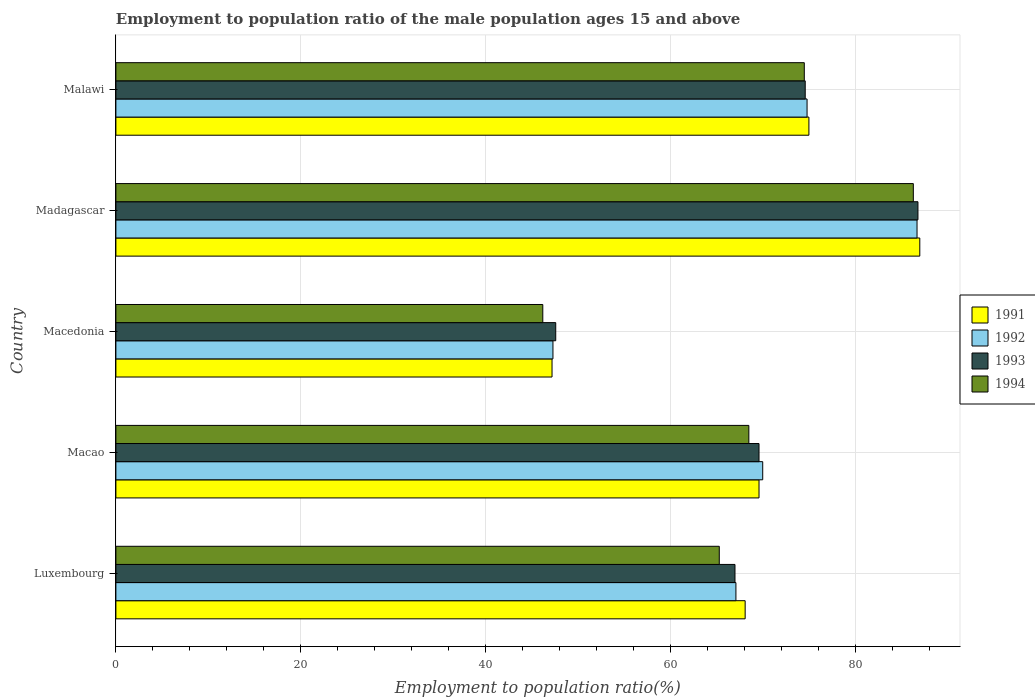How many different coloured bars are there?
Offer a very short reply. 4. How many groups of bars are there?
Offer a very short reply. 5. Are the number of bars per tick equal to the number of legend labels?
Provide a succinct answer. Yes. Are the number of bars on each tick of the Y-axis equal?
Your answer should be very brief. Yes. How many bars are there on the 2nd tick from the bottom?
Provide a succinct answer. 4. What is the label of the 5th group of bars from the top?
Provide a succinct answer. Luxembourg. What is the employment to population ratio in 1992 in Malawi?
Give a very brief answer. 74.8. Across all countries, what is the maximum employment to population ratio in 1992?
Give a very brief answer. 86.7. Across all countries, what is the minimum employment to population ratio in 1992?
Provide a short and direct response. 47.3. In which country was the employment to population ratio in 1991 maximum?
Provide a short and direct response. Madagascar. In which country was the employment to population ratio in 1992 minimum?
Your answer should be compact. Macedonia. What is the total employment to population ratio in 1994 in the graph?
Your response must be concise. 340.8. What is the difference between the employment to population ratio in 1994 in Macedonia and that in Malawi?
Your answer should be very brief. -28.3. What is the difference between the employment to population ratio in 1992 in Luxembourg and the employment to population ratio in 1993 in Madagascar?
Provide a succinct answer. -19.7. What is the average employment to population ratio in 1994 per country?
Ensure brevity in your answer.  68.16. What is the difference between the employment to population ratio in 1992 and employment to population ratio in 1993 in Macao?
Give a very brief answer. 0.4. In how many countries, is the employment to population ratio in 1991 greater than 32 %?
Offer a very short reply. 5. What is the ratio of the employment to population ratio in 1992 in Luxembourg to that in Macao?
Offer a terse response. 0.96. Is the employment to population ratio in 1994 in Luxembourg less than that in Malawi?
Offer a terse response. Yes. Is the difference between the employment to population ratio in 1992 in Madagascar and Malawi greater than the difference between the employment to population ratio in 1993 in Madagascar and Malawi?
Offer a very short reply. No. What is the difference between the highest and the second highest employment to population ratio in 1992?
Provide a short and direct response. 11.9. What is the difference between the highest and the lowest employment to population ratio in 1993?
Your answer should be compact. 39.2. Is it the case that in every country, the sum of the employment to population ratio in 1992 and employment to population ratio in 1994 is greater than the sum of employment to population ratio in 1991 and employment to population ratio in 1993?
Offer a terse response. No. Is it the case that in every country, the sum of the employment to population ratio in 1991 and employment to population ratio in 1994 is greater than the employment to population ratio in 1993?
Make the answer very short. Yes. Are all the bars in the graph horizontal?
Provide a succinct answer. Yes. How many countries are there in the graph?
Offer a terse response. 5. Are the values on the major ticks of X-axis written in scientific E-notation?
Make the answer very short. No. Does the graph contain grids?
Keep it short and to the point. Yes. Where does the legend appear in the graph?
Your response must be concise. Center right. What is the title of the graph?
Provide a short and direct response. Employment to population ratio of the male population ages 15 and above. What is the label or title of the Y-axis?
Ensure brevity in your answer.  Country. What is the Employment to population ratio(%) in 1991 in Luxembourg?
Keep it short and to the point. 68.1. What is the Employment to population ratio(%) in 1992 in Luxembourg?
Offer a terse response. 67.1. What is the Employment to population ratio(%) in 1993 in Luxembourg?
Offer a terse response. 67. What is the Employment to population ratio(%) in 1994 in Luxembourg?
Your response must be concise. 65.3. What is the Employment to population ratio(%) in 1991 in Macao?
Ensure brevity in your answer.  69.6. What is the Employment to population ratio(%) in 1992 in Macao?
Your answer should be compact. 70. What is the Employment to population ratio(%) of 1993 in Macao?
Give a very brief answer. 69.6. What is the Employment to population ratio(%) of 1994 in Macao?
Give a very brief answer. 68.5. What is the Employment to population ratio(%) of 1991 in Macedonia?
Provide a succinct answer. 47.2. What is the Employment to population ratio(%) of 1992 in Macedonia?
Your response must be concise. 47.3. What is the Employment to population ratio(%) in 1993 in Macedonia?
Provide a short and direct response. 47.6. What is the Employment to population ratio(%) of 1994 in Macedonia?
Give a very brief answer. 46.2. What is the Employment to population ratio(%) of 1992 in Madagascar?
Give a very brief answer. 86.7. What is the Employment to population ratio(%) in 1993 in Madagascar?
Make the answer very short. 86.8. What is the Employment to population ratio(%) in 1994 in Madagascar?
Provide a succinct answer. 86.3. What is the Employment to population ratio(%) in 1992 in Malawi?
Keep it short and to the point. 74.8. What is the Employment to population ratio(%) of 1993 in Malawi?
Your response must be concise. 74.6. What is the Employment to population ratio(%) of 1994 in Malawi?
Your answer should be compact. 74.5. Across all countries, what is the maximum Employment to population ratio(%) of 1991?
Your answer should be very brief. 87. Across all countries, what is the maximum Employment to population ratio(%) in 1992?
Your answer should be compact. 86.7. Across all countries, what is the maximum Employment to population ratio(%) of 1993?
Offer a terse response. 86.8. Across all countries, what is the maximum Employment to population ratio(%) in 1994?
Provide a succinct answer. 86.3. Across all countries, what is the minimum Employment to population ratio(%) of 1991?
Provide a short and direct response. 47.2. Across all countries, what is the minimum Employment to population ratio(%) of 1992?
Provide a succinct answer. 47.3. Across all countries, what is the minimum Employment to population ratio(%) in 1993?
Offer a very short reply. 47.6. Across all countries, what is the minimum Employment to population ratio(%) in 1994?
Ensure brevity in your answer.  46.2. What is the total Employment to population ratio(%) in 1991 in the graph?
Your response must be concise. 346.9. What is the total Employment to population ratio(%) of 1992 in the graph?
Your answer should be very brief. 345.9. What is the total Employment to population ratio(%) in 1993 in the graph?
Make the answer very short. 345.6. What is the total Employment to population ratio(%) of 1994 in the graph?
Your answer should be very brief. 340.8. What is the difference between the Employment to population ratio(%) in 1991 in Luxembourg and that in Macao?
Provide a short and direct response. -1.5. What is the difference between the Employment to population ratio(%) in 1992 in Luxembourg and that in Macao?
Offer a terse response. -2.9. What is the difference between the Employment to population ratio(%) in 1994 in Luxembourg and that in Macao?
Give a very brief answer. -3.2. What is the difference between the Employment to population ratio(%) of 1991 in Luxembourg and that in Macedonia?
Give a very brief answer. 20.9. What is the difference between the Employment to population ratio(%) of 1992 in Luxembourg and that in Macedonia?
Offer a very short reply. 19.8. What is the difference between the Employment to population ratio(%) in 1994 in Luxembourg and that in Macedonia?
Offer a very short reply. 19.1. What is the difference between the Employment to population ratio(%) in 1991 in Luxembourg and that in Madagascar?
Ensure brevity in your answer.  -18.9. What is the difference between the Employment to population ratio(%) of 1992 in Luxembourg and that in Madagascar?
Your answer should be compact. -19.6. What is the difference between the Employment to population ratio(%) in 1993 in Luxembourg and that in Madagascar?
Your response must be concise. -19.8. What is the difference between the Employment to population ratio(%) in 1994 in Luxembourg and that in Madagascar?
Ensure brevity in your answer.  -21. What is the difference between the Employment to population ratio(%) of 1991 in Luxembourg and that in Malawi?
Your answer should be very brief. -6.9. What is the difference between the Employment to population ratio(%) of 1992 in Luxembourg and that in Malawi?
Provide a succinct answer. -7.7. What is the difference between the Employment to population ratio(%) in 1993 in Luxembourg and that in Malawi?
Your answer should be compact. -7.6. What is the difference between the Employment to population ratio(%) in 1991 in Macao and that in Macedonia?
Provide a short and direct response. 22.4. What is the difference between the Employment to population ratio(%) in 1992 in Macao and that in Macedonia?
Keep it short and to the point. 22.7. What is the difference between the Employment to population ratio(%) of 1994 in Macao and that in Macedonia?
Offer a terse response. 22.3. What is the difference between the Employment to population ratio(%) in 1991 in Macao and that in Madagascar?
Offer a very short reply. -17.4. What is the difference between the Employment to population ratio(%) of 1992 in Macao and that in Madagascar?
Give a very brief answer. -16.7. What is the difference between the Employment to population ratio(%) of 1993 in Macao and that in Madagascar?
Your response must be concise. -17.2. What is the difference between the Employment to population ratio(%) of 1994 in Macao and that in Madagascar?
Your answer should be very brief. -17.8. What is the difference between the Employment to population ratio(%) in 1991 in Macao and that in Malawi?
Your answer should be compact. -5.4. What is the difference between the Employment to population ratio(%) in 1992 in Macao and that in Malawi?
Keep it short and to the point. -4.8. What is the difference between the Employment to population ratio(%) of 1993 in Macao and that in Malawi?
Provide a succinct answer. -5. What is the difference between the Employment to population ratio(%) of 1991 in Macedonia and that in Madagascar?
Offer a very short reply. -39.8. What is the difference between the Employment to population ratio(%) of 1992 in Macedonia and that in Madagascar?
Offer a very short reply. -39.4. What is the difference between the Employment to population ratio(%) in 1993 in Macedonia and that in Madagascar?
Keep it short and to the point. -39.2. What is the difference between the Employment to population ratio(%) in 1994 in Macedonia and that in Madagascar?
Offer a terse response. -40.1. What is the difference between the Employment to population ratio(%) of 1991 in Macedonia and that in Malawi?
Offer a terse response. -27.8. What is the difference between the Employment to population ratio(%) of 1992 in Macedonia and that in Malawi?
Provide a short and direct response. -27.5. What is the difference between the Employment to population ratio(%) of 1994 in Macedonia and that in Malawi?
Your response must be concise. -28.3. What is the difference between the Employment to population ratio(%) of 1991 in Madagascar and that in Malawi?
Provide a short and direct response. 12. What is the difference between the Employment to population ratio(%) of 1993 in Madagascar and that in Malawi?
Provide a short and direct response. 12.2. What is the difference between the Employment to population ratio(%) of 1991 in Luxembourg and the Employment to population ratio(%) of 1992 in Macao?
Provide a short and direct response. -1.9. What is the difference between the Employment to population ratio(%) of 1991 in Luxembourg and the Employment to population ratio(%) of 1993 in Macao?
Offer a terse response. -1.5. What is the difference between the Employment to population ratio(%) in 1991 in Luxembourg and the Employment to population ratio(%) in 1994 in Macao?
Your answer should be compact. -0.4. What is the difference between the Employment to population ratio(%) in 1991 in Luxembourg and the Employment to population ratio(%) in 1992 in Macedonia?
Provide a short and direct response. 20.8. What is the difference between the Employment to population ratio(%) in 1991 in Luxembourg and the Employment to population ratio(%) in 1994 in Macedonia?
Ensure brevity in your answer.  21.9. What is the difference between the Employment to population ratio(%) of 1992 in Luxembourg and the Employment to population ratio(%) of 1993 in Macedonia?
Your answer should be compact. 19.5. What is the difference between the Employment to population ratio(%) of 1992 in Luxembourg and the Employment to population ratio(%) of 1994 in Macedonia?
Your answer should be very brief. 20.9. What is the difference between the Employment to population ratio(%) of 1993 in Luxembourg and the Employment to population ratio(%) of 1994 in Macedonia?
Make the answer very short. 20.8. What is the difference between the Employment to population ratio(%) in 1991 in Luxembourg and the Employment to population ratio(%) in 1992 in Madagascar?
Give a very brief answer. -18.6. What is the difference between the Employment to population ratio(%) of 1991 in Luxembourg and the Employment to population ratio(%) of 1993 in Madagascar?
Offer a very short reply. -18.7. What is the difference between the Employment to population ratio(%) of 1991 in Luxembourg and the Employment to population ratio(%) of 1994 in Madagascar?
Provide a short and direct response. -18.2. What is the difference between the Employment to population ratio(%) in 1992 in Luxembourg and the Employment to population ratio(%) in 1993 in Madagascar?
Keep it short and to the point. -19.7. What is the difference between the Employment to population ratio(%) in 1992 in Luxembourg and the Employment to population ratio(%) in 1994 in Madagascar?
Your answer should be compact. -19.2. What is the difference between the Employment to population ratio(%) in 1993 in Luxembourg and the Employment to population ratio(%) in 1994 in Madagascar?
Your response must be concise. -19.3. What is the difference between the Employment to population ratio(%) in 1991 in Luxembourg and the Employment to population ratio(%) in 1992 in Malawi?
Offer a very short reply. -6.7. What is the difference between the Employment to population ratio(%) of 1992 in Luxembourg and the Employment to population ratio(%) of 1994 in Malawi?
Give a very brief answer. -7.4. What is the difference between the Employment to population ratio(%) in 1991 in Macao and the Employment to population ratio(%) in 1992 in Macedonia?
Your answer should be compact. 22.3. What is the difference between the Employment to population ratio(%) of 1991 in Macao and the Employment to population ratio(%) of 1994 in Macedonia?
Give a very brief answer. 23.4. What is the difference between the Employment to population ratio(%) of 1992 in Macao and the Employment to population ratio(%) of 1993 in Macedonia?
Offer a very short reply. 22.4. What is the difference between the Employment to population ratio(%) of 1992 in Macao and the Employment to population ratio(%) of 1994 in Macedonia?
Offer a terse response. 23.8. What is the difference between the Employment to population ratio(%) in 1993 in Macao and the Employment to population ratio(%) in 1994 in Macedonia?
Your answer should be compact. 23.4. What is the difference between the Employment to population ratio(%) of 1991 in Macao and the Employment to population ratio(%) of 1992 in Madagascar?
Your answer should be compact. -17.1. What is the difference between the Employment to population ratio(%) of 1991 in Macao and the Employment to population ratio(%) of 1993 in Madagascar?
Your answer should be very brief. -17.2. What is the difference between the Employment to population ratio(%) of 1991 in Macao and the Employment to population ratio(%) of 1994 in Madagascar?
Ensure brevity in your answer.  -16.7. What is the difference between the Employment to population ratio(%) of 1992 in Macao and the Employment to population ratio(%) of 1993 in Madagascar?
Offer a terse response. -16.8. What is the difference between the Employment to population ratio(%) of 1992 in Macao and the Employment to population ratio(%) of 1994 in Madagascar?
Give a very brief answer. -16.3. What is the difference between the Employment to population ratio(%) of 1993 in Macao and the Employment to population ratio(%) of 1994 in Madagascar?
Your response must be concise. -16.7. What is the difference between the Employment to population ratio(%) of 1991 in Macao and the Employment to population ratio(%) of 1992 in Malawi?
Keep it short and to the point. -5.2. What is the difference between the Employment to population ratio(%) of 1991 in Macao and the Employment to population ratio(%) of 1994 in Malawi?
Offer a very short reply. -4.9. What is the difference between the Employment to population ratio(%) in 1992 in Macao and the Employment to population ratio(%) in 1993 in Malawi?
Make the answer very short. -4.6. What is the difference between the Employment to population ratio(%) in 1991 in Macedonia and the Employment to population ratio(%) in 1992 in Madagascar?
Your response must be concise. -39.5. What is the difference between the Employment to population ratio(%) in 1991 in Macedonia and the Employment to population ratio(%) in 1993 in Madagascar?
Provide a succinct answer. -39.6. What is the difference between the Employment to population ratio(%) of 1991 in Macedonia and the Employment to population ratio(%) of 1994 in Madagascar?
Offer a very short reply. -39.1. What is the difference between the Employment to population ratio(%) in 1992 in Macedonia and the Employment to population ratio(%) in 1993 in Madagascar?
Keep it short and to the point. -39.5. What is the difference between the Employment to population ratio(%) in 1992 in Macedonia and the Employment to population ratio(%) in 1994 in Madagascar?
Provide a succinct answer. -39. What is the difference between the Employment to population ratio(%) in 1993 in Macedonia and the Employment to population ratio(%) in 1994 in Madagascar?
Your answer should be very brief. -38.7. What is the difference between the Employment to population ratio(%) in 1991 in Macedonia and the Employment to population ratio(%) in 1992 in Malawi?
Make the answer very short. -27.6. What is the difference between the Employment to population ratio(%) of 1991 in Macedonia and the Employment to population ratio(%) of 1993 in Malawi?
Provide a short and direct response. -27.4. What is the difference between the Employment to population ratio(%) of 1991 in Macedonia and the Employment to population ratio(%) of 1994 in Malawi?
Provide a succinct answer. -27.3. What is the difference between the Employment to population ratio(%) in 1992 in Macedonia and the Employment to population ratio(%) in 1993 in Malawi?
Your answer should be compact. -27.3. What is the difference between the Employment to population ratio(%) in 1992 in Macedonia and the Employment to population ratio(%) in 1994 in Malawi?
Your answer should be compact. -27.2. What is the difference between the Employment to population ratio(%) of 1993 in Macedonia and the Employment to population ratio(%) of 1994 in Malawi?
Provide a short and direct response. -26.9. What is the difference between the Employment to population ratio(%) in 1991 in Madagascar and the Employment to population ratio(%) in 1994 in Malawi?
Offer a terse response. 12.5. What is the difference between the Employment to population ratio(%) in 1992 in Madagascar and the Employment to population ratio(%) in 1993 in Malawi?
Your response must be concise. 12.1. What is the difference between the Employment to population ratio(%) in 1993 in Madagascar and the Employment to population ratio(%) in 1994 in Malawi?
Provide a succinct answer. 12.3. What is the average Employment to population ratio(%) of 1991 per country?
Offer a very short reply. 69.38. What is the average Employment to population ratio(%) in 1992 per country?
Ensure brevity in your answer.  69.18. What is the average Employment to population ratio(%) in 1993 per country?
Make the answer very short. 69.12. What is the average Employment to population ratio(%) of 1994 per country?
Provide a succinct answer. 68.16. What is the difference between the Employment to population ratio(%) in 1991 and Employment to population ratio(%) in 1993 in Luxembourg?
Make the answer very short. 1.1. What is the difference between the Employment to population ratio(%) in 1991 and Employment to population ratio(%) in 1994 in Luxembourg?
Ensure brevity in your answer.  2.8. What is the difference between the Employment to population ratio(%) in 1992 and Employment to population ratio(%) in 1993 in Luxembourg?
Make the answer very short. 0.1. What is the difference between the Employment to population ratio(%) of 1993 and Employment to population ratio(%) of 1994 in Luxembourg?
Your response must be concise. 1.7. What is the difference between the Employment to population ratio(%) in 1991 and Employment to population ratio(%) in 1992 in Macao?
Offer a terse response. -0.4. What is the difference between the Employment to population ratio(%) in 1992 and Employment to population ratio(%) in 1993 in Macao?
Your response must be concise. 0.4. What is the difference between the Employment to population ratio(%) of 1993 and Employment to population ratio(%) of 1994 in Macao?
Offer a very short reply. 1.1. What is the difference between the Employment to population ratio(%) in 1991 and Employment to population ratio(%) in 1993 in Macedonia?
Make the answer very short. -0.4. What is the difference between the Employment to population ratio(%) in 1992 and Employment to population ratio(%) in 1993 in Macedonia?
Provide a short and direct response. -0.3. What is the difference between the Employment to population ratio(%) in 1993 and Employment to population ratio(%) in 1994 in Macedonia?
Offer a very short reply. 1.4. What is the difference between the Employment to population ratio(%) in 1991 and Employment to population ratio(%) in 1994 in Madagascar?
Offer a terse response. 0.7. What is the difference between the Employment to population ratio(%) of 1992 and Employment to population ratio(%) of 1993 in Madagascar?
Offer a very short reply. -0.1. What is the difference between the Employment to population ratio(%) of 1992 and Employment to population ratio(%) of 1994 in Madagascar?
Offer a terse response. 0.4. What is the difference between the Employment to population ratio(%) in 1993 and Employment to population ratio(%) in 1994 in Madagascar?
Make the answer very short. 0.5. What is the difference between the Employment to population ratio(%) of 1991 and Employment to population ratio(%) of 1992 in Malawi?
Provide a short and direct response. 0.2. What is the difference between the Employment to population ratio(%) in 1992 and Employment to population ratio(%) in 1994 in Malawi?
Provide a succinct answer. 0.3. What is the ratio of the Employment to population ratio(%) of 1991 in Luxembourg to that in Macao?
Offer a terse response. 0.98. What is the ratio of the Employment to population ratio(%) of 1992 in Luxembourg to that in Macao?
Offer a terse response. 0.96. What is the ratio of the Employment to population ratio(%) of 1993 in Luxembourg to that in Macao?
Give a very brief answer. 0.96. What is the ratio of the Employment to population ratio(%) of 1994 in Luxembourg to that in Macao?
Your answer should be compact. 0.95. What is the ratio of the Employment to population ratio(%) of 1991 in Luxembourg to that in Macedonia?
Your response must be concise. 1.44. What is the ratio of the Employment to population ratio(%) of 1992 in Luxembourg to that in Macedonia?
Offer a very short reply. 1.42. What is the ratio of the Employment to population ratio(%) of 1993 in Luxembourg to that in Macedonia?
Keep it short and to the point. 1.41. What is the ratio of the Employment to population ratio(%) of 1994 in Luxembourg to that in Macedonia?
Offer a terse response. 1.41. What is the ratio of the Employment to population ratio(%) in 1991 in Luxembourg to that in Madagascar?
Give a very brief answer. 0.78. What is the ratio of the Employment to population ratio(%) in 1992 in Luxembourg to that in Madagascar?
Your answer should be very brief. 0.77. What is the ratio of the Employment to population ratio(%) of 1993 in Luxembourg to that in Madagascar?
Ensure brevity in your answer.  0.77. What is the ratio of the Employment to population ratio(%) in 1994 in Luxembourg to that in Madagascar?
Offer a terse response. 0.76. What is the ratio of the Employment to population ratio(%) in 1991 in Luxembourg to that in Malawi?
Keep it short and to the point. 0.91. What is the ratio of the Employment to population ratio(%) of 1992 in Luxembourg to that in Malawi?
Provide a succinct answer. 0.9. What is the ratio of the Employment to population ratio(%) in 1993 in Luxembourg to that in Malawi?
Ensure brevity in your answer.  0.9. What is the ratio of the Employment to population ratio(%) of 1994 in Luxembourg to that in Malawi?
Provide a succinct answer. 0.88. What is the ratio of the Employment to population ratio(%) of 1991 in Macao to that in Macedonia?
Provide a short and direct response. 1.47. What is the ratio of the Employment to population ratio(%) of 1992 in Macao to that in Macedonia?
Offer a very short reply. 1.48. What is the ratio of the Employment to population ratio(%) of 1993 in Macao to that in Macedonia?
Make the answer very short. 1.46. What is the ratio of the Employment to population ratio(%) of 1994 in Macao to that in Macedonia?
Your answer should be very brief. 1.48. What is the ratio of the Employment to population ratio(%) of 1992 in Macao to that in Madagascar?
Provide a succinct answer. 0.81. What is the ratio of the Employment to population ratio(%) of 1993 in Macao to that in Madagascar?
Provide a succinct answer. 0.8. What is the ratio of the Employment to population ratio(%) in 1994 in Macao to that in Madagascar?
Provide a succinct answer. 0.79. What is the ratio of the Employment to population ratio(%) in 1991 in Macao to that in Malawi?
Your answer should be compact. 0.93. What is the ratio of the Employment to population ratio(%) of 1992 in Macao to that in Malawi?
Your response must be concise. 0.94. What is the ratio of the Employment to population ratio(%) in 1993 in Macao to that in Malawi?
Offer a very short reply. 0.93. What is the ratio of the Employment to population ratio(%) in 1994 in Macao to that in Malawi?
Your answer should be very brief. 0.92. What is the ratio of the Employment to population ratio(%) in 1991 in Macedonia to that in Madagascar?
Make the answer very short. 0.54. What is the ratio of the Employment to population ratio(%) of 1992 in Macedonia to that in Madagascar?
Your answer should be very brief. 0.55. What is the ratio of the Employment to population ratio(%) in 1993 in Macedonia to that in Madagascar?
Keep it short and to the point. 0.55. What is the ratio of the Employment to population ratio(%) of 1994 in Macedonia to that in Madagascar?
Make the answer very short. 0.54. What is the ratio of the Employment to population ratio(%) in 1991 in Macedonia to that in Malawi?
Provide a succinct answer. 0.63. What is the ratio of the Employment to population ratio(%) of 1992 in Macedonia to that in Malawi?
Provide a short and direct response. 0.63. What is the ratio of the Employment to population ratio(%) of 1993 in Macedonia to that in Malawi?
Make the answer very short. 0.64. What is the ratio of the Employment to population ratio(%) in 1994 in Macedonia to that in Malawi?
Your response must be concise. 0.62. What is the ratio of the Employment to population ratio(%) of 1991 in Madagascar to that in Malawi?
Make the answer very short. 1.16. What is the ratio of the Employment to population ratio(%) in 1992 in Madagascar to that in Malawi?
Make the answer very short. 1.16. What is the ratio of the Employment to population ratio(%) of 1993 in Madagascar to that in Malawi?
Your answer should be very brief. 1.16. What is the ratio of the Employment to population ratio(%) of 1994 in Madagascar to that in Malawi?
Your answer should be compact. 1.16. What is the difference between the highest and the second highest Employment to population ratio(%) of 1991?
Make the answer very short. 12. What is the difference between the highest and the second highest Employment to population ratio(%) in 1992?
Offer a very short reply. 11.9. What is the difference between the highest and the second highest Employment to population ratio(%) in 1993?
Ensure brevity in your answer.  12.2. What is the difference between the highest and the second highest Employment to population ratio(%) in 1994?
Your answer should be compact. 11.8. What is the difference between the highest and the lowest Employment to population ratio(%) in 1991?
Keep it short and to the point. 39.8. What is the difference between the highest and the lowest Employment to population ratio(%) in 1992?
Provide a succinct answer. 39.4. What is the difference between the highest and the lowest Employment to population ratio(%) in 1993?
Your answer should be very brief. 39.2. What is the difference between the highest and the lowest Employment to population ratio(%) of 1994?
Offer a terse response. 40.1. 